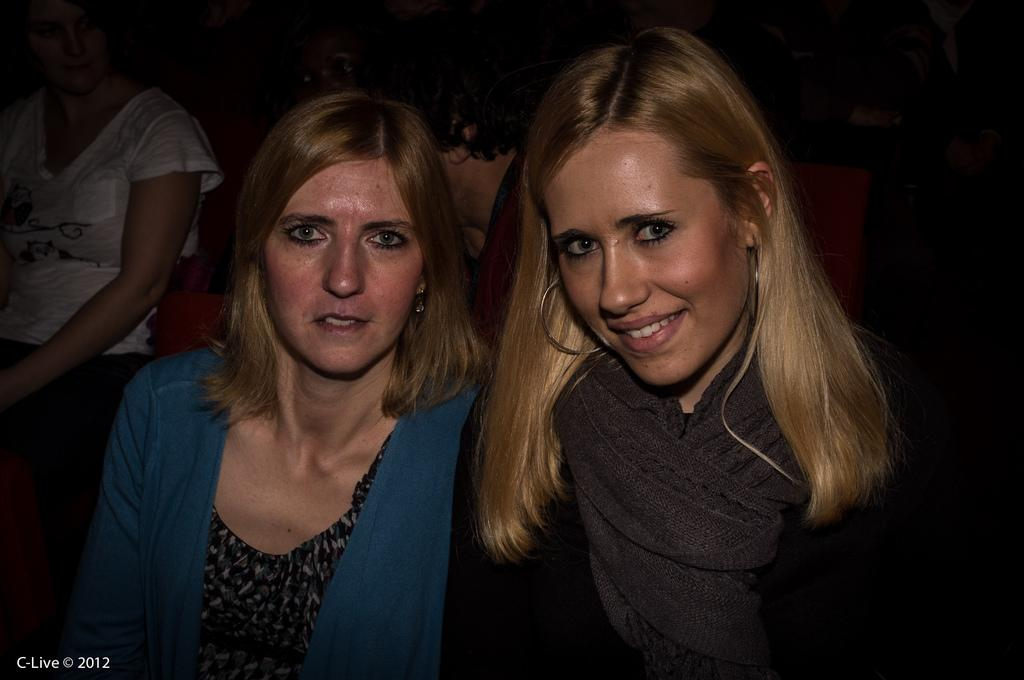Who or what is present in the image? There are people in the image. What can be observed about the background of the image? The background of the image is dark. Is there any text or additional information visible in the image? Yes, there is text and a year visible in the bottom left side of the image. Can you see any mice or soup in the image? No, there are no mice or soup present in the image. Is there a cellar visible in the image? There is no mention of a cellar in the provided facts, so it cannot be determined if one is present in the image. 